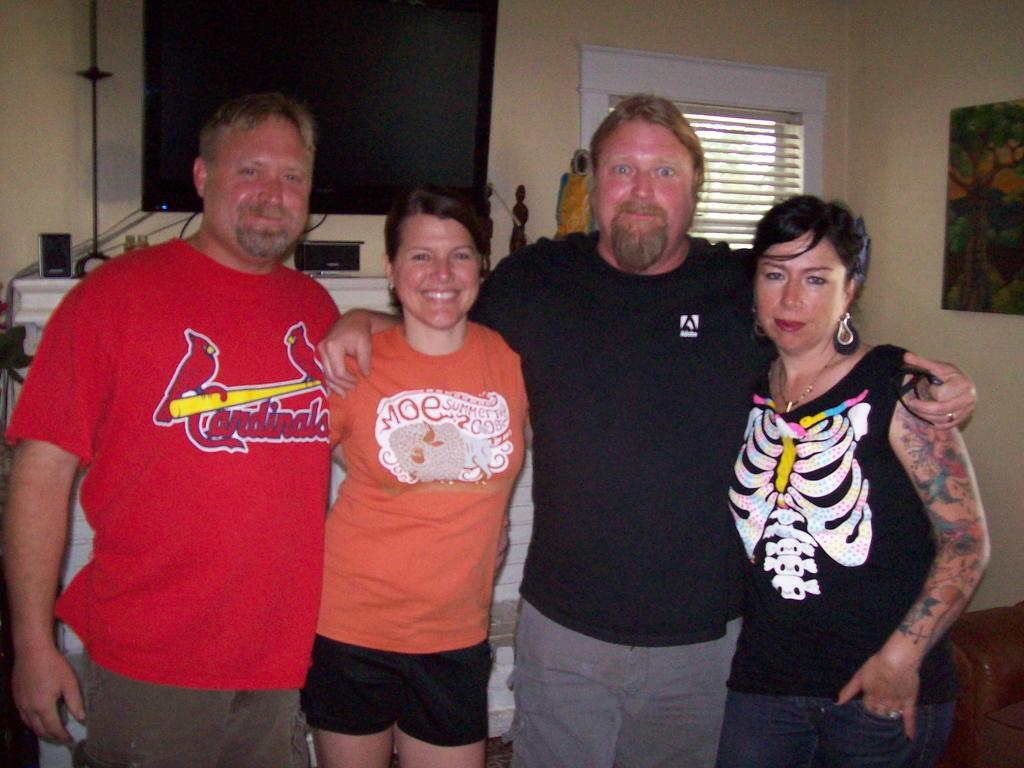<image>
Relay a brief, clear account of the picture shown. A man in a Cardinals t-shirt poses with three other people. 